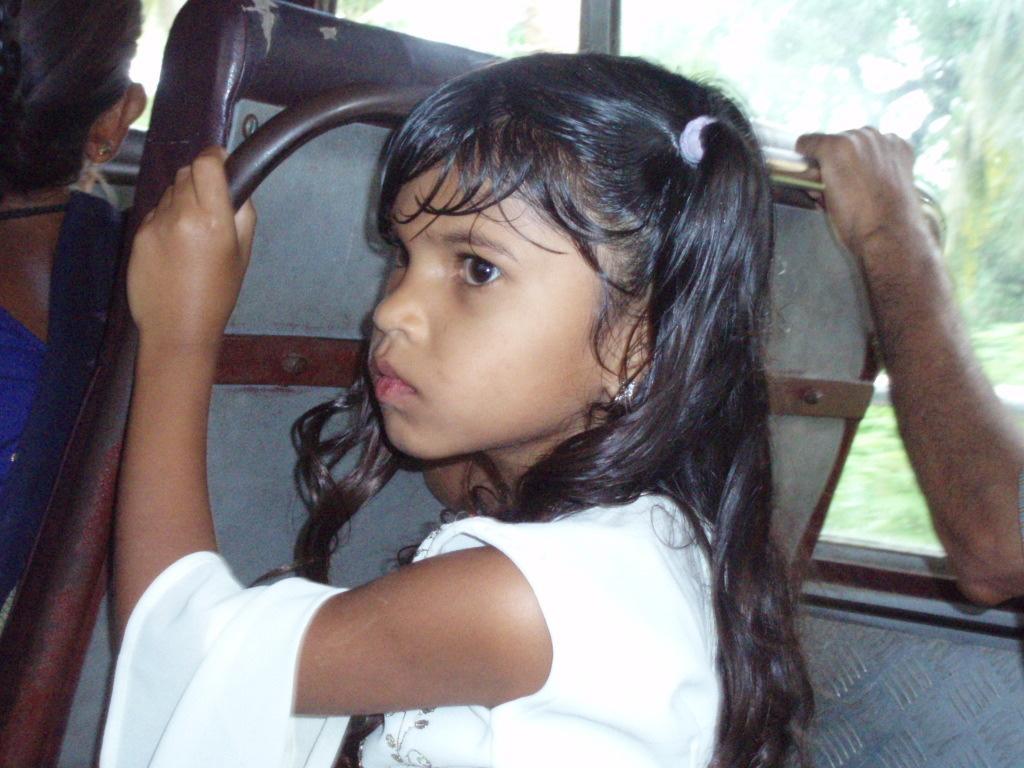How would you summarize this image in a sentence or two? In this picture I can see there is a girl sitting in a bus seat and she is looking at left side and there is another person sitting beside her. The girl is holding a seat which is in front of her and there is a woman sitting in the front seat. 